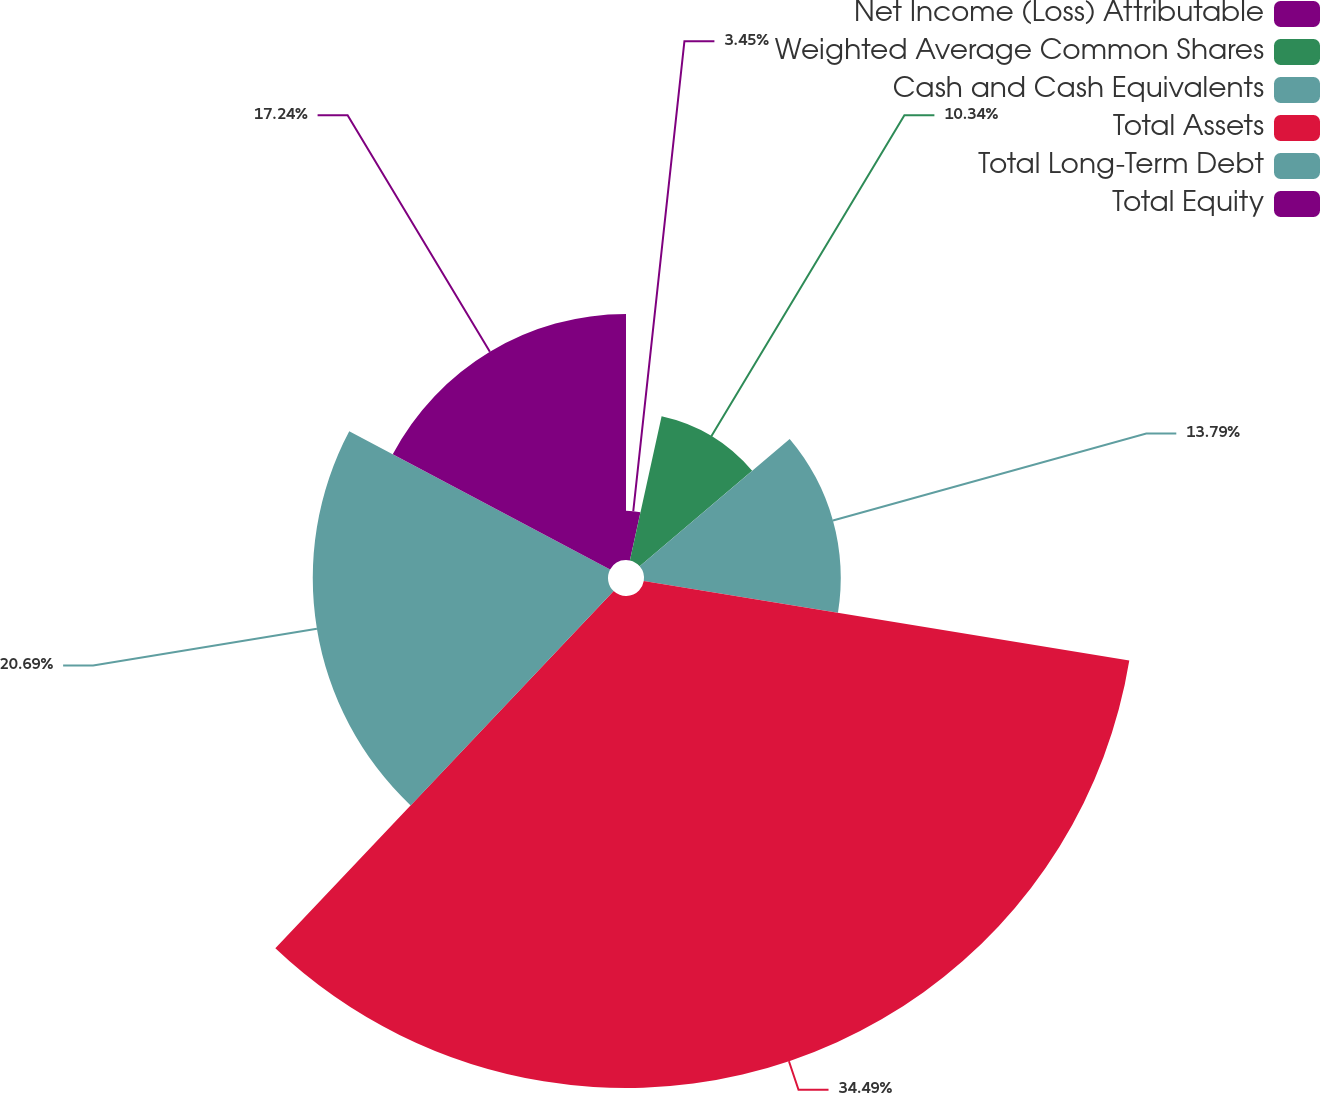Convert chart to OTSL. <chart><loc_0><loc_0><loc_500><loc_500><pie_chart><fcel>Net Income (Loss) Attributable<fcel>Weighted Average Common Shares<fcel>Cash and Cash Equivalents<fcel>Total Assets<fcel>Total Long-Term Debt<fcel>Total Equity<nl><fcel>3.45%<fcel>10.34%<fcel>13.79%<fcel>34.48%<fcel>20.69%<fcel>17.24%<nl></chart> 